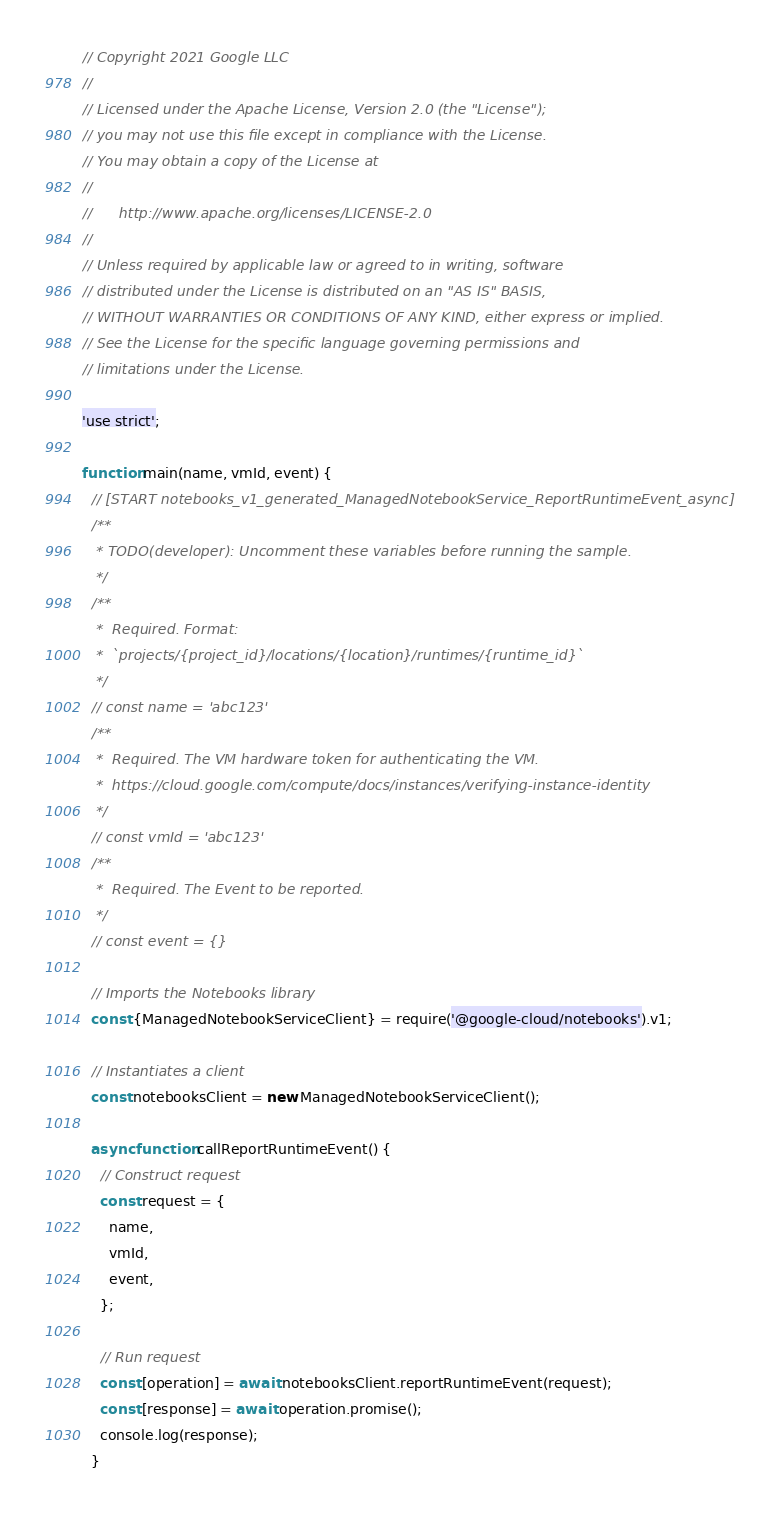Convert code to text. <code><loc_0><loc_0><loc_500><loc_500><_JavaScript_>// Copyright 2021 Google LLC
//
// Licensed under the Apache License, Version 2.0 (the "License");
// you may not use this file except in compliance with the License.
// You may obtain a copy of the License at
//
//      http://www.apache.org/licenses/LICENSE-2.0
//
// Unless required by applicable law or agreed to in writing, software
// distributed under the License is distributed on an "AS IS" BASIS,
// WITHOUT WARRANTIES OR CONDITIONS OF ANY KIND, either express or implied.
// See the License for the specific language governing permissions and
// limitations under the License.

'use strict';

function main(name, vmId, event) {
  // [START notebooks_v1_generated_ManagedNotebookService_ReportRuntimeEvent_async]
  /**
   * TODO(developer): Uncomment these variables before running the sample.
   */
  /**
   *  Required. Format:
   *  `projects/{project_id}/locations/{location}/runtimes/{runtime_id}`
   */
  // const name = 'abc123'
  /**
   *  Required. The VM hardware token for authenticating the VM.
   *  https://cloud.google.com/compute/docs/instances/verifying-instance-identity
   */
  // const vmId = 'abc123'
  /**
   *  Required. The Event to be reported.
   */
  // const event = {}

  // Imports the Notebooks library
  const {ManagedNotebookServiceClient} = require('@google-cloud/notebooks').v1;

  // Instantiates a client
  const notebooksClient = new ManagedNotebookServiceClient();

  async function callReportRuntimeEvent() {
    // Construct request
    const request = {
      name,
      vmId,
      event,
    };

    // Run request
    const [operation] = await notebooksClient.reportRuntimeEvent(request);
    const [response] = await operation.promise();
    console.log(response);
  }
</code> 